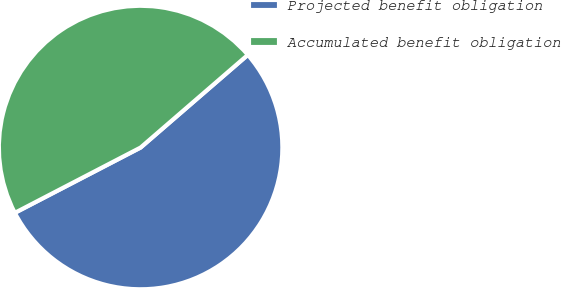Convert chart to OTSL. <chart><loc_0><loc_0><loc_500><loc_500><pie_chart><fcel>Projected benefit obligation<fcel>Accumulated benefit obligation<nl><fcel>53.72%<fcel>46.28%<nl></chart> 